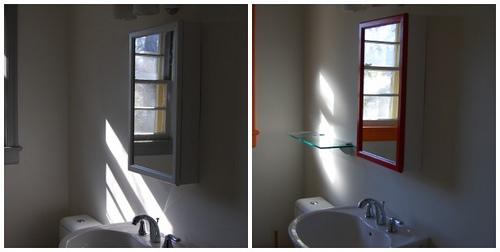What are two differences between the photos?
Keep it brief. Frame light. Are the cabinets the same?
Be succinct. No. Was the picture taken during the day?
Quick response, please. Yes. 